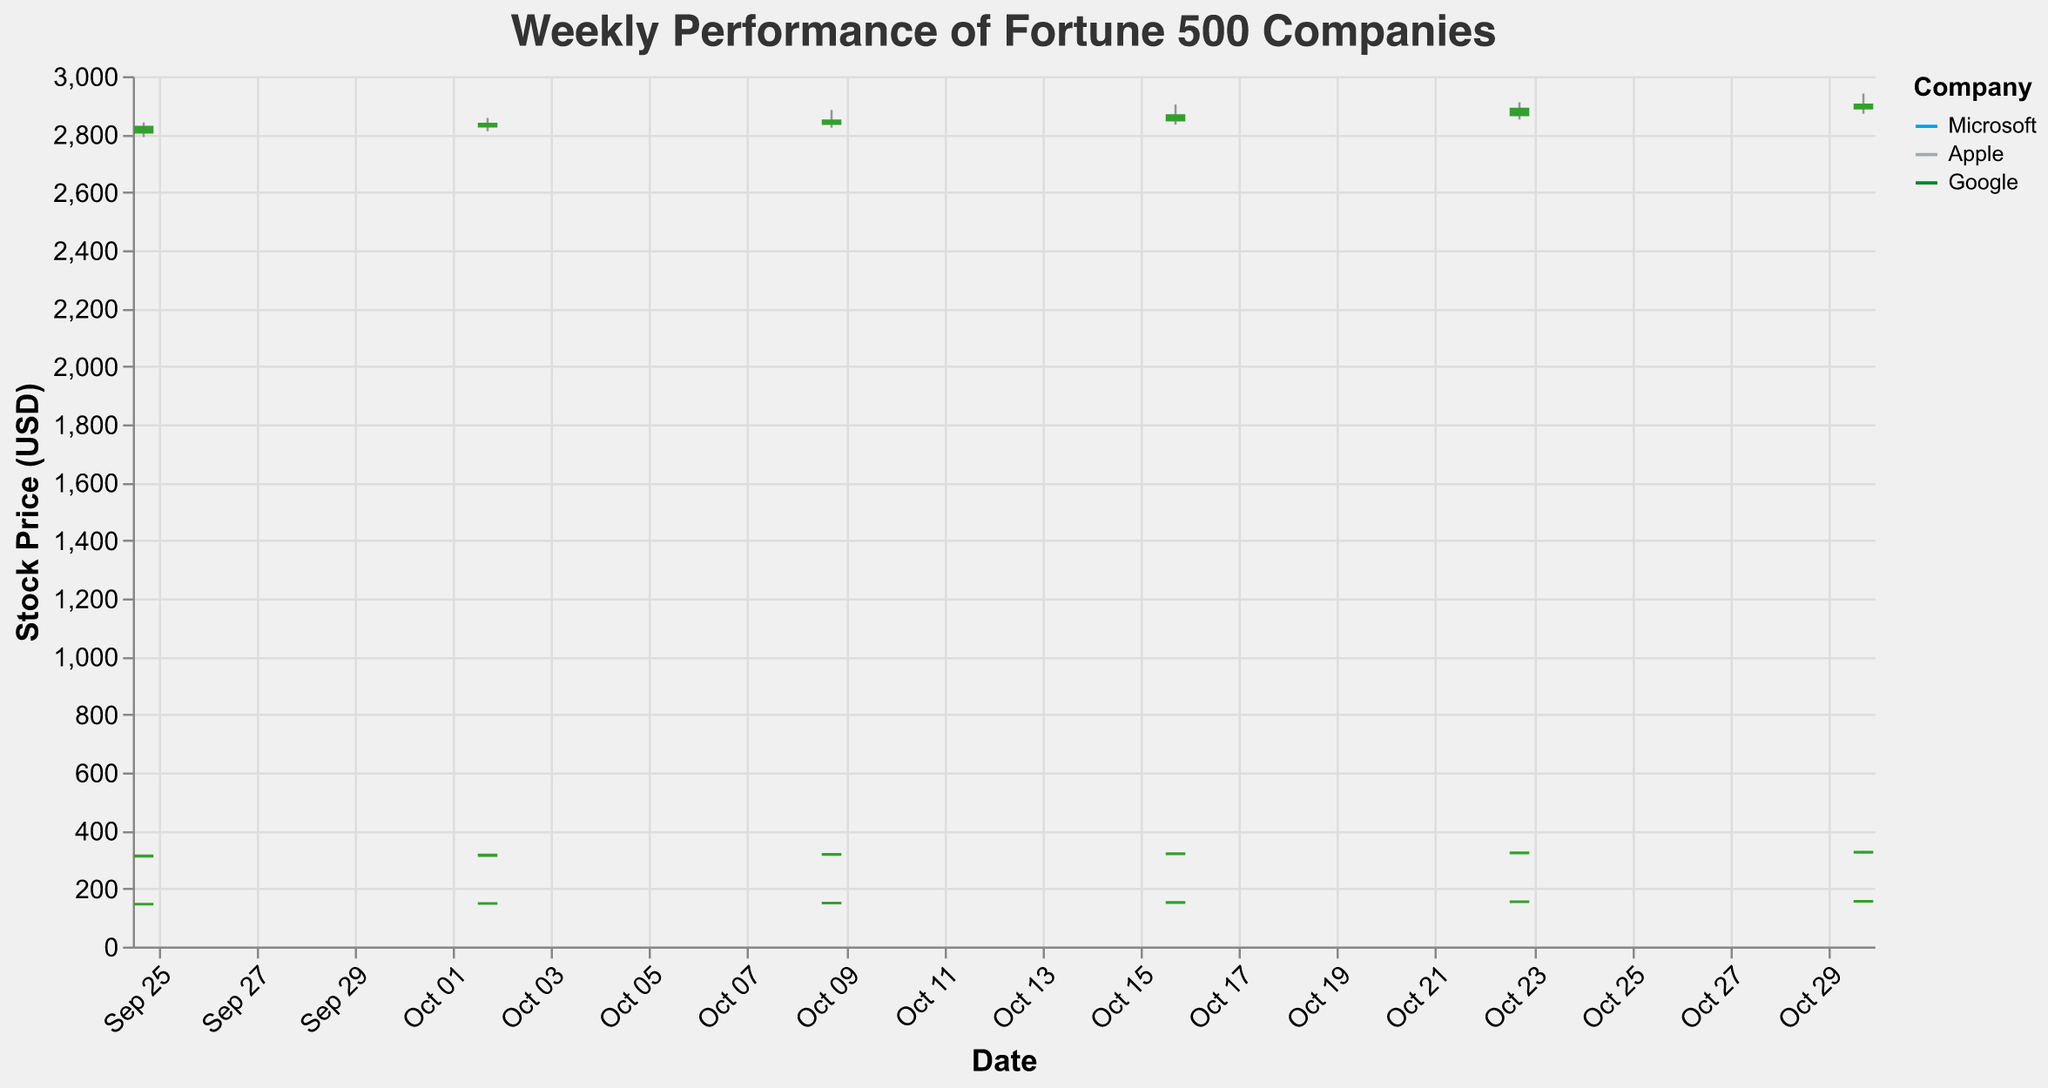What's the title of the figure? The title is centered at the top of the chart.
Answer: "Weekly Performance of Fortune 500 Companies" On which date did Microsoft have the highest closing price? To answer, look for the highest "Close" value for Microsoft across the different dates.
Answer: 2023-10-30 What is the range of stock prices for Apple on 2023-10-23? Subtract the 'Low' from the 'High' value for Apple on 2023-10-23.
Answer: 4.8 USD Which company consistently showed an increasing trend in its closing prices from 2023-09-25 to 2023-10-30? Look at the 'Close' values of all companies for each date and identify which company shows a noticeable upward trajectory.
Answer: Google What was the highest trading volume for Microsoft during the period? Identify the highest 'Volume' value for Microsoft from the given data.
Answer: 52123000 How did Apple's stock price on 2023-10-02 compare to its price on 2023-10-09? Compare the 'Close' prices of Apple on the two mentioned dates.
Answer: Increased by 1.25 USD Which company's stock had the largest high-to-low range on 2023-10-09? Compute the high-to-low difference for all companies on that date and find the largest one.
Answer: Google What is the average closing price of Google over the given period? Sum up all the 'Close' prices for Google and divide by the number of dates. Calculation: (2825.30 + 2835.60 + 2847.00 + 2865.35 + 2887.50 + 2901.75) / 6.
Answer: 2860.08 USD Did any company's stock price drop below the opening price on 2023-10-16? Check if 'Close' is less than 'Open' for any company on the mentioned date.
Answer: No 